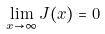Convert formula to latex. <formula><loc_0><loc_0><loc_500><loc_500>\lim _ { x \to \infty } J ( x ) = 0</formula> 